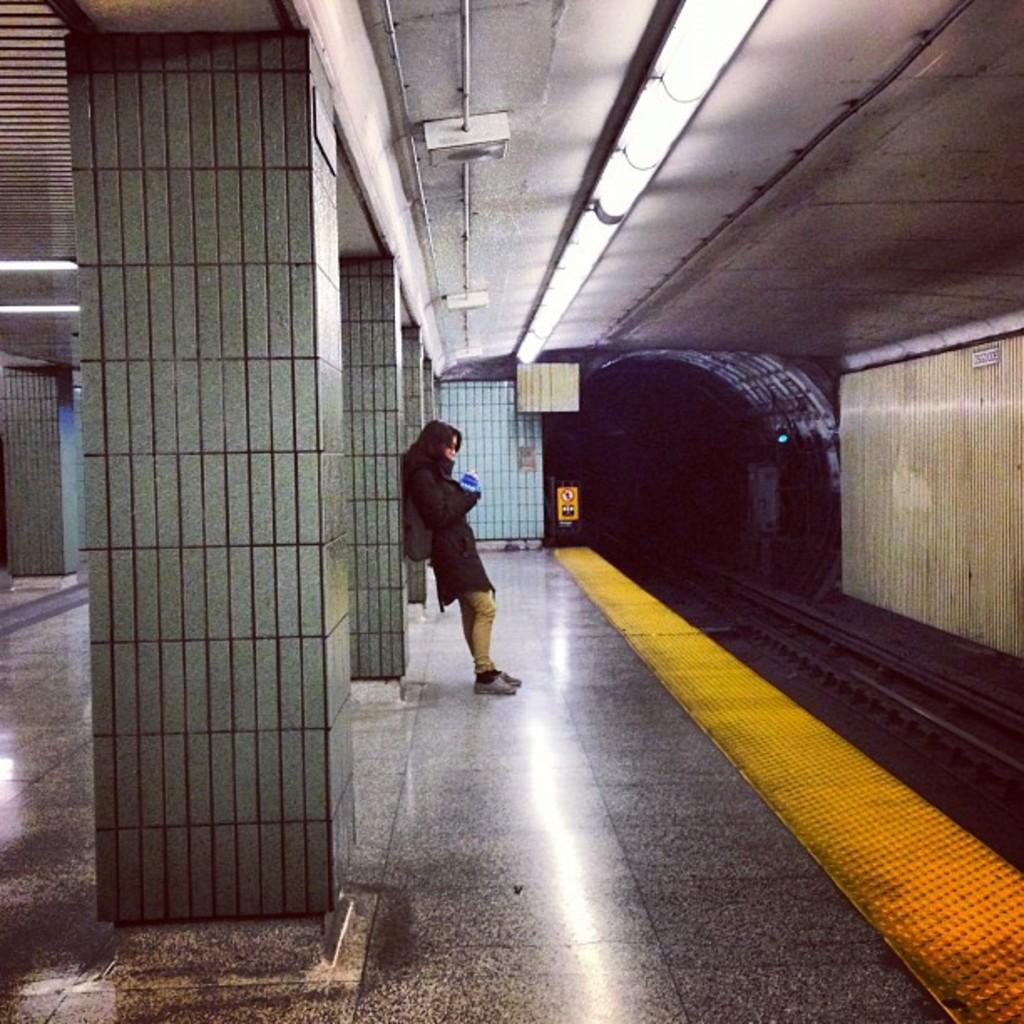What type of structure can be seen in the image? There are pillars and a roof in the image, suggesting a building or structure. What can be found inside the structure? There are lights, a tunnel, a train track, a signboard, and a platform visible in the image. Is there anyone present in the image? Yes, there is a person in the image. What else can be seen in the image? There are objects in the image, which could include various items or details. Can you see any balloons floating in the air in the image? No, there are no balloons visible in the image. Is there a ring on the person's finger in the image? There is no information about the person's attire or accessories in the image, so it cannot be determined if they are wearing a ring. 